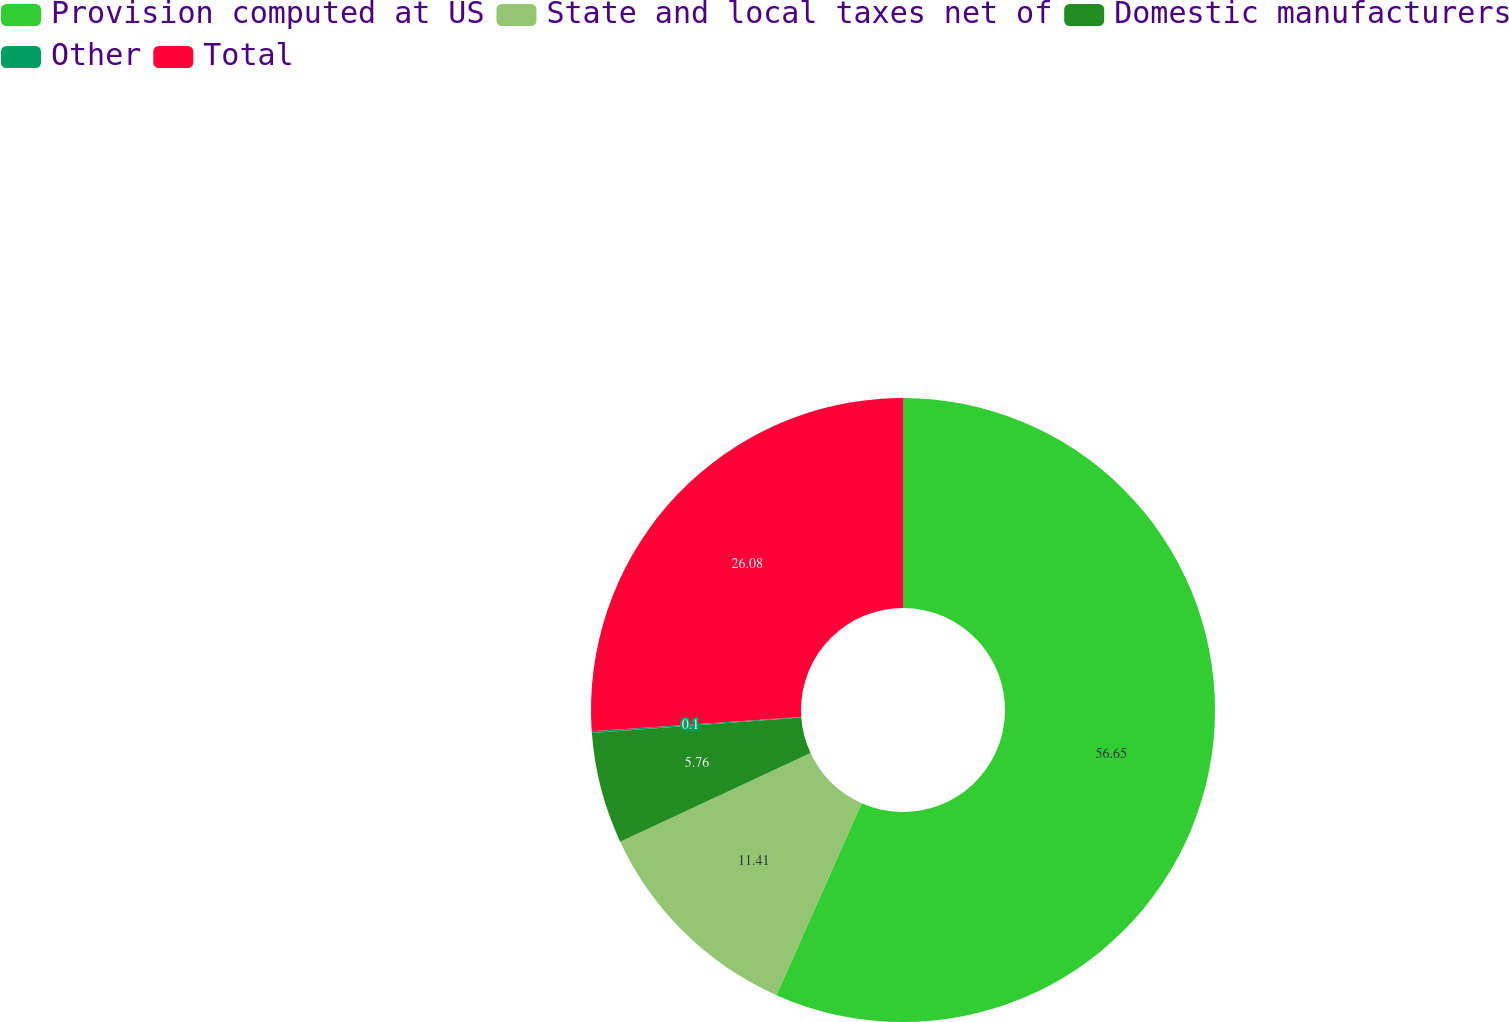Convert chart. <chart><loc_0><loc_0><loc_500><loc_500><pie_chart><fcel>Provision computed at US<fcel>State and local taxes net of<fcel>Domestic manufacturers<fcel>Other<fcel>Total<nl><fcel>56.65%<fcel>11.41%<fcel>5.76%<fcel>0.1%<fcel>26.08%<nl></chart> 